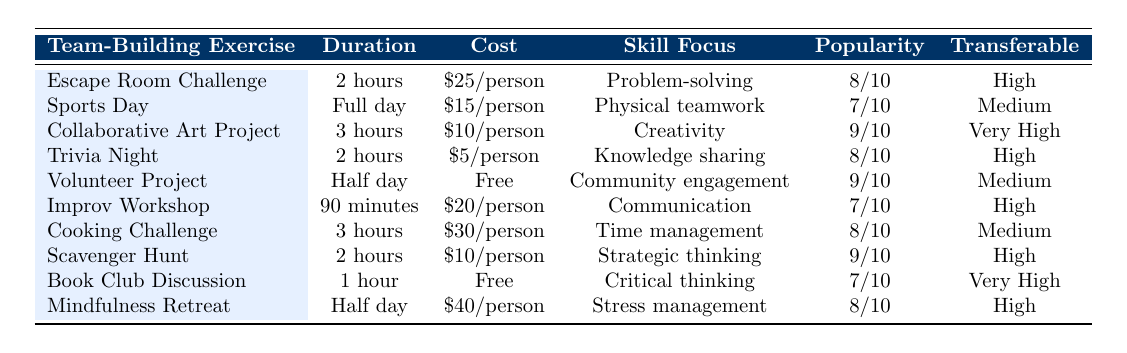What is the duration of the Escape Room Challenge? The duration for the Escape Room Challenge is listed directly in the table under the "Duration" column. It states "2 hours."
Answer: 2 hours Which team-building exercise has the highest cost per person? From the "Cost" column, the Cooking Challenge has the highest cost listed at "$30/person." By comparing other costs, it is clear that no other exercise exceeds this amount.
Answer: Cooking Challenge Are there any team-building exercises that are free? The "Cost" column shows that both the Volunteer Project and the Book Club Discussion are marked as "Free." Thus, there are indeed team-building exercises that do not require payment.
Answer: Yes What is the average popularity score among all exercises? To find the average, we convert the scores from the "Popularity Among Teachers" column to numerical values: (8 + 7 + 9 + 8 + 9 + 7 + 8 + 9 + 7 + 8) = 80. There are 10 exercises, so the average is 80/10 = 8.
Answer: 8 Which exercise has a very high transferability to the classroom and focuses on creativity? By looking at the "Transferable to Classroom" and "Skill Focus" columns, the Collaborative Art Project is marked as "Very High" for transferability and focuses on "Creativity," matching both criteria.
Answer: Collaborative Art Project Is the duration of the Cooking Challenge greater than 2 hours? The duration of the Cooking Challenge is noted as "3 hours" in the table. Since "3 hours" is greater than "2 hours," the answer is affirmative.
Answer: Yes Which exercise requires the shortest duration? Reviewing the "Duration" column, the Book Club Discussion is only "1 hour," making it the shortest among all listed exercises.
Answer: Book Club Discussion How many exercises have a medium transferability rating? By referencing the "Transferable to Classroom" column, we identify three exercises: Sports Day, Cooking Challenge, and Volunteer Project, which all are marked as "Medium."
Answer: 3 In terms of skill focus, which exercise is centered on communication and what is its popularity score? The exercise focusing on communication is the Improv Workshop, which has a popularity score of "7/10" listed in the table.
Answer: Improv Workshop, 7/10 